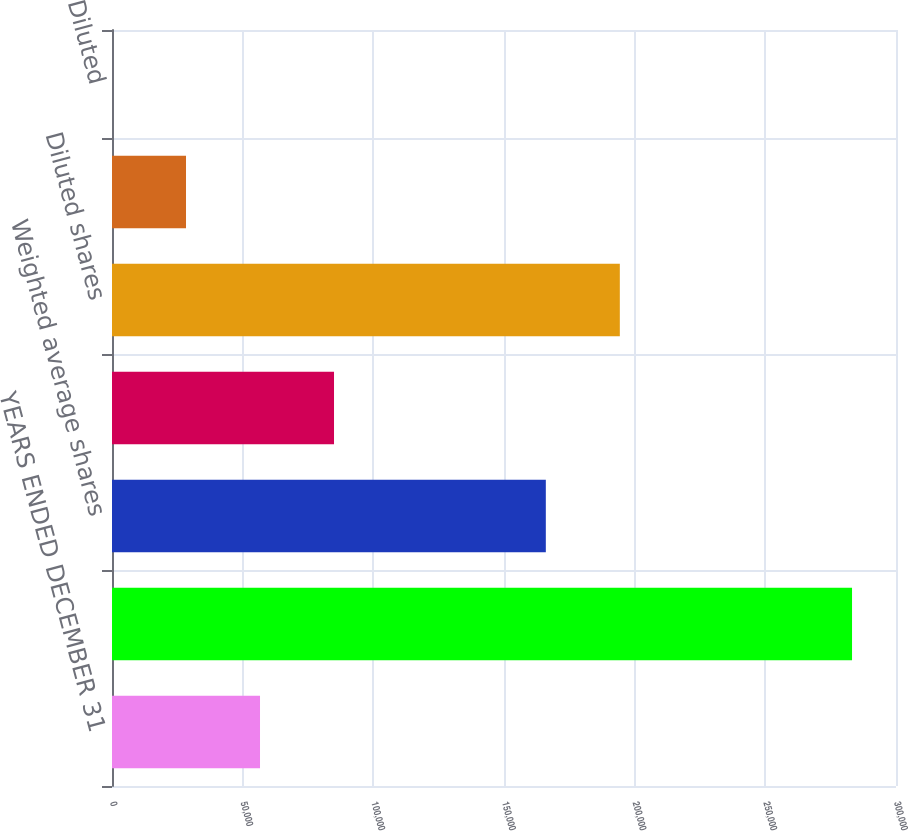Convert chart to OTSL. <chart><loc_0><loc_0><loc_500><loc_500><bar_chart><fcel>YEARS ENDED DECEMBER 31<fcel>Net Income<fcel>Weighted average shares<fcel>Potentially dilutive shares<fcel>Diluted shares<fcel>Basic<fcel>Diluted<nl><fcel>56636.9<fcel>283178<fcel>166003<fcel>84954.5<fcel>194321<fcel>28319.3<fcel>1.65<nl></chart> 